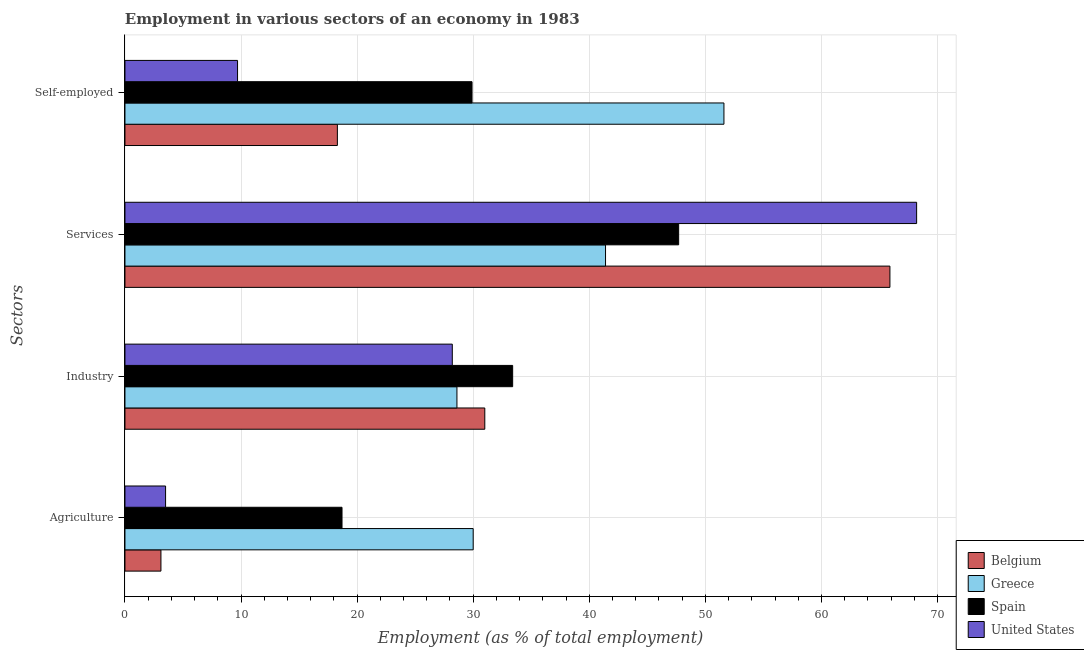How many different coloured bars are there?
Give a very brief answer. 4. How many groups of bars are there?
Offer a terse response. 4. Are the number of bars per tick equal to the number of legend labels?
Provide a succinct answer. Yes. Are the number of bars on each tick of the Y-axis equal?
Keep it short and to the point. Yes. What is the label of the 3rd group of bars from the top?
Keep it short and to the point. Industry. What is the percentage of self employed workers in Belgium?
Your answer should be very brief. 18.3. Across all countries, what is the maximum percentage of workers in industry?
Provide a succinct answer. 33.4. Across all countries, what is the minimum percentage of workers in services?
Provide a succinct answer. 41.4. What is the total percentage of workers in industry in the graph?
Offer a very short reply. 121.2. What is the difference between the percentage of workers in industry in United States and that in Belgium?
Offer a very short reply. -2.8. What is the difference between the percentage of self employed workers in Belgium and the percentage of workers in industry in Greece?
Provide a succinct answer. -10.3. What is the average percentage of workers in industry per country?
Provide a succinct answer. 30.3. What is the difference between the percentage of self employed workers and percentage of workers in services in Belgium?
Your answer should be compact. -47.6. What is the ratio of the percentage of workers in services in Greece to that in Spain?
Ensure brevity in your answer.  0.87. Is the percentage of workers in industry in Greece less than that in Spain?
Your answer should be very brief. Yes. Is the difference between the percentage of self employed workers in Spain and United States greater than the difference between the percentage of workers in services in Spain and United States?
Your answer should be compact. Yes. What is the difference between the highest and the second highest percentage of workers in industry?
Offer a very short reply. 2.4. What is the difference between the highest and the lowest percentage of workers in industry?
Provide a succinct answer. 5.2. Is the sum of the percentage of self employed workers in Greece and United States greater than the maximum percentage of workers in services across all countries?
Make the answer very short. No. Is it the case that in every country, the sum of the percentage of self employed workers and percentage of workers in services is greater than the sum of percentage of workers in agriculture and percentage of workers in industry?
Your response must be concise. No. What does the 1st bar from the bottom in Services represents?
Offer a very short reply. Belgium. Is it the case that in every country, the sum of the percentage of workers in agriculture and percentage of workers in industry is greater than the percentage of workers in services?
Your answer should be compact. No. How many bars are there?
Your response must be concise. 16. How many countries are there in the graph?
Your answer should be compact. 4. What is the difference between two consecutive major ticks on the X-axis?
Your answer should be compact. 10. Are the values on the major ticks of X-axis written in scientific E-notation?
Your answer should be compact. No. Does the graph contain any zero values?
Your response must be concise. No. Does the graph contain grids?
Offer a terse response. Yes. How many legend labels are there?
Make the answer very short. 4. How are the legend labels stacked?
Ensure brevity in your answer.  Vertical. What is the title of the graph?
Your answer should be very brief. Employment in various sectors of an economy in 1983. Does "Hungary" appear as one of the legend labels in the graph?
Give a very brief answer. No. What is the label or title of the X-axis?
Provide a succinct answer. Employment (as % of total employment). What is the label or title of the Y-axis?
Provide a short and direct response. Sectors. What is the Employment (as % of total employment) in Belgium in Agriculture?
Provide a succinct answer. 3.1. What is the Employment (as % of total employment) in Greece in Agriculture?
Provide a short and direct response. 30. What is the Employment (as % of total employment) in Spain in Agriculture?
Offer a terse response. 18.7. What is the Employment (as % of total employment) of Belgium in Industry?
Provide a succinct answer. 31. What is the Employment (as % of total employment) of Greece in Industry?
Give a very brief answer. 28.6. What is the Employment (as % of total employment) of Spain in Industry?
Offer a very short reply. 33.4. What is the Employment (as % of total employment) in United States in Industry?
Your answer should be very brief. 28.2. What is the Employment (as % of total employment) of Belgium in Services?
Your response must be concise. 65.9. What is the Employment (as % of total employment) in Greece in Services?
Offer a very short reply. 41.4. What is the Employment (as % of total employment) of Spain in Services?
Your answer should be very brief. 47.7. What is the Employment (as % of total employment) in United States in Services?
Provide a succinct answer. 68.2. What is the Employment (as % of total employment) in Belgium in Self-employed?
Provide a succinct answer. 18.3. What is the Employment (as % of total employment) of Greece in Self-employed?
Offer a terse response. 51.6. What is the Employment (as % of total employment) in Spain in Self-employed?
Keep it short and to the point. 29.9. What is the Employment (as % of total employment) of United States in Self-employed?
Offer a very short reply. 9.7. Across all Sectors, what is the maximum Employment (as % of total employment) in Belgium?
Provide a succinct answer. 65.9. Across all Sectors, what is the maximum Employment (as % of total employment) in Greece?
Provide a succinct answer. 51.6. Across all Sectors, what is the maximum Employment (as % of total employment) in Spain?
Your response must be concise. 47.7. Across all Sectors, what is the maximum Employment (as % of total employment) in United States?
Your answer should be compact. 68.2. Across all Sectors, what is the minimum Employment (as % of total employment) of Belgium?
Your response must be concise. 3.1. Across all Sectors, what is the minimum Employment (as % of total employment) of Greece?
Provide a succinct answer. 28.6. Across all Sectors, what is the minimum Employment (as % of total employment) in Spain?
Provide a short and direct response. 18.7. Across all Sectors, what is the minimum Employment (as % of total employment) of United States?
Offer a very short reply. 3.5. What is the total Employment (as % of total employment) in Belgium in the graph?
Provide a short and direct response. 118.3. What is the total Employment (as % of total employment) in Greece in the graph?
Your answer should be compact. 151.6. What is the total Employment (as % of total employment) in Spain in the graph?
Your answer should be compact. 129.7. What is the total Employment (as % of total employment) of United States in the graph?
Your answer should be very brief. 109.6. What is the difference between the Employment (as % of total employment) of Belgium in Agriculture and that in Industry?
Keep it short and to the point. -27.9. What is the difference between the Employment (as % of total employment) of Greece in Agriculture and that in Industry?
Offer a very short reply. 1.4. What is the difference between the Employment (as % of total employment) of Spain in Agriculture and that in Industry?
Provide a short and direct response. -14.7. What is the difference between the Employment (as % of total employment) in United States in Agriculture and that in Industry?
Ensure brevity in your answer.  -24.7. What is the difference between the Employment (as % of total employment) of Belgium in Agriculture and that in Services?
Give a very brief answer. -62.8. What is the difference between the Employment (as % of total employment) of United States in Agriculture and that in Services?
Your answer should be very brief. -64.7. What is the difference between the Employment (as % of total employment) of Belgium in Agriculture and that in Self-employed?
Keep it short and to the point. -15.2. What is the difference between the Employment (as % of total employment) in Greece in Agriculture and that in Self-employed?
Your response must be concise. -21.6. What is the difference between the Employment (as % of total employment) in Belgium in Industry and that in Services?
Ensure brevity in your answer.  -34.9. What is the difference between the Employment (as % of total employment) in Spain in Industry and that in Services?
Provide a succinct answer. -14.3. What is the difference between the Employment (as % of total employment) in United States in Industry and that in Services?
Make the answer very short. -40. What is the difference between the Employment (as % of total employment) of Belgium in Industry and that in Self-employed?
Your response must be concise. 12.7. What is the difference between the Employment (as % of total employment) in Spain in Industry and that in Self-employed?
Offer a very short reply. 3.5. What is the difference between the Employment (as % of total employment) of Belgium in Services and that in Self-employed?
Provide a short and direct response. 47.6. What is the difference between the Employment (as % of total employment) of Greece in Services and that in Self-employed?
Your answer should be compact. -10.2. What is the difference between the Employment (as % of total employment) of United States in Services and that in Self-employed?
Offer a very short reply. 58.5. What is the difference between the Employment (as % of total employment) in Belgium in Agriculture and the Employment (as % of total employment) in Greece in Industry?
Offer a terse response. -25.5. What is the difference between the Employment (as % of total employment) of Belgium in Agriculture and the Employment (as % of total employment) of Spain in Industry?
Offer a terse response. -30.3. What is the difference between the Employment (as % of total employment) of Belgium in Agriculture and the Employment (as % of total employment) of United States in Industry?
Give a very brief answer. -25.1. What is the difference between the Employment (as % of total employment) of Spain in Agriculture and the Employment (as % of total employment) of United States in Industry?
Make the answer very short. -9.5. What is the difference between the Employment (as % of total employment) in Belgium in Agriculture and the Employment (as % of total employment) in Greece in Services?
Your answer should be compact. -38.3. What is the difference between the Employment (as % of total employment) of Belgium in Agriculture and the Employment (as % of total employment) of Spain in Services?
Your answer should be compact. -44.6. What is the difference between the Employment (as % of total employment) in Belgium in Agriculture and the Employment (as % of total employment) in United States in Services?
Your answer should be compact. -65.1. What is the difference between the Employment (as % of total employment) in Greece in Agriculture and the Employment (as % of total employment) in Spain in Services?
Make the answer very short. -17.7. What is the difference between the Employment (as % of total employment) in Greece in Agriculture and the Employment (as % of total employment) in United States in Services?
Your answer should be compact. -38.2. What is the difference between the Employment (as % of total employment) in Spain in Agriculture and the Employment (as % of total employment) in United States in Services?
Your answer should be very brief. -49.5. What is the difference between the Employment (as % of total employment) of Belgium in Agriculture and the Employment (as % of total employment) of Greece in Self-employed?
Offer a terse response. -48.5. What is the difference between the Employment (as % of total employment) in Belgium in Agriculture and the Employment (as % of total employment) in Spain in Self-employed?
Make the answer very short. -26.8. What is the difference between the Employment (as % of total employment) in Greece in Agriculture and the Employment (as % of total employment) in Spain in Self-employed?
Offer a terse response. 0.1. What is the difference between the Employment (as % of total employment) of Greece in Agriculture and the Employment (as % of total employment) of United States in Self-employed?
Provide a succinct answer. 20.3. What is the difference between the Employment (as % of total employment) of Spain in Agriculture and the Employment (as % of total employment) of United States in Self-employed?
Give a very brief answer. 9. What is the difference between the Employment (as % of total employment) of Belgium in Industry and the Employment (as % of total employment) of Spain in Services?
Your answer should be compact. -16.7. What is the difference between the Employment (as % of total employment) in Belgium in Industry and the Employment (as % of total employment) in United States in Services?
Your response must be concise. -37.2. What is the difference between the Employment (as % of total employment) in Greece in Industry and the Employment (as % of total employment) in Spain in Services?
Provide a short and direct response. -19.1. What is the difference between the Employment (as % of total employment) in Greece in Industry and the Employment (as % of total employment) in United States in Services?
Your answer should be compact. -39.6. What is the difference between the Employment (as % of total employment) in Spain in Industry and the Employment (as % of total employment) in United States in Services?
Give a very brief answer. -34.8. What is the difference between the Employment (as % of total employment) in Belgium in Industry and the Employment (as % of total employment) in Greece in Self-employed?
Give a very brief answer. -20.6. What is the difference between the Employment (as % of total employment) in Belgium in Industry and the Employment (as % of total employment) in Spain in Self-employed?
Give a very brief answer. 1.1. What is the difference between the Employment (as % of total employment) of Belgium in Industry and the Employment (as % of total employment) of United States in Self-employed?
Give a very brief answer. 21.3. What is the difference between the Employment (as % of total employment) in Greece in Industry and the Employment (as % of total employment) in Spain in Self-employed?
Offer a terse response. -1.3. What is the difference between the Employment (as % of total employment) of Greece in Industry and the Employment (as % of total employment) of United States in Self-employed?
Make the answer very short. 18.9. What is the difference between the Employment (as % of total employment) of Spain in Industry and the Employment (as % of total employment) of United States in Self-employed?
Ensure brevity in your answer.  23.7. What is the difference between the Employment (as % of total employment) of Belgium in Services and the Employment (as % of total employment) of Greece in Self-employed?
Ensure brevity in your answer.  14.3. What is the difference between the Employment (as % of total employment) in Belgium in Services and the Employment (as % of total employment) in Spain in Self-employed?
Offer a terse response. 36. What is the difference between the Employment (as % of total employment) of Belgium in Services and the Employment (as % of total employment) of United States in Self-employed?
Ensure brevity in your answer.  56.2. What is the difference between the Employment (as % of total employment) in Greece in Services and the Employment (as % of total employment) in Spain in Self-employed?
Provide a short and direct response. 11.5. What is the difference between the Employment (as % of total employment) in Greece in Services and the Employment (as % of total employment) in United States in Self-employed?
Provide a short and direct response. 31.7. What is the difference between the Employment (as % of total employment) of Spain in Services and the Employment (as % of total employment) of United States in Self-employed?
Provide a succinct answer. 38. What is the average Employment (as % of total employment) of Belgium per Sectors?
Give a very brief answer. 29.57. What is the average Employment (as % of total employment) in Greece per Sectors?
Your response must be concise. 37.9. What is the average Employment (as % of total employment) of Spain per Sectors?
Keep it short and to the point. 32.42. What is the average Employment (as % of total employment) in United States per Sectors?
Offer a very short reply. 27.4. What is the difference between the Employment (as % of total employment) of Belgium and Employment (as % of total employment) of Greece in Agriculture?
Provide a succinct answer. -26.9. What is the difference between the Employment (as % of total employment) in Belgium and Employment (as % of total employment) in Spain in Agriculture?
Your response must be concise. -15.6. What is the difference between the Employment (as % of total employment) of Greece and Employment (as % of total employment) of United States in Agriculture?
Make the answer very short. 26.5. What is the difference between the Employment (as % of total employment) of Belgium and Employment (as % of total employment) of Greece in Industry?
Ensure brevity in your answer.  2.4. What is the difference between the Employment (as % of total employment) in Belgium and Employment (as % of total employment) in United States in Industry?
Your answer should be very brief. 2.8. What is the difference between the Employment (as % of total employment) of Greece and Employment (as % of total employment) of Spain in Industry?
Your response must be concise. -4.8. What is the difference between the Employment (as % of total employment) of Greece and Employment (as % of total employment) of United States in Industry?
Give a very brief answer. 0.4. What is the difference between the Employment (as % of total employment) of Belgium and Employment (as % of total employment) of Spain in Services?
Offer a terse response. 18.2. What is the difference between the Employment (as % of total employment) in Belgium and Employment (as % of total employment) in United States in Services?
Provide a short and direct response. -2.3. What is the difference between the Employment (as % of total employment) in Greece and Employment (as % of total employment) in Spain in Services?
Your answer should be compact. -6.3. What is the difference between the Employment (as % of total employment) of Greece and Employment (as % of total employment) of United States in Services?
Ensure brevity in your answer.  -26.8. What is the difference between the Employment (as % of total employment) of Spain and Employment (as % of total employment) of United States in Services?
Your answer should be very brief. -20.5. What is the difference between the Employment (as % of total employment) of Belgium and Employment (as % of total employment) of Greece in Self-employed?
Your answer should be compact. -33.3. What is the difference between the Employment (as % of total employment) in Belgium and Employment (as % of total employment) in United States in Self-employed?
Offer a very short reply. 8.6. What is the difference between the Employment (as % of total employment) of Greece and Employment (as % of total employment) of Spain in Self-employed?
Offer a terse response. 21.7. What is the difference between the Employment (as % of total employment) of Greece and Employment (as % of total employment) of United States in Self-employed?
Offer a very short reply. 41.9. What is the difference between the Employment (as % of total employment) of Spain and Employment (as % of total employment) of United States in Self-employed?
Keep it short and to the point. 20.2. What is the ratio of the Employment (as % of total employment) in Belgium in Agriculture to that in Industry?
Provide a succinct answer. 0.1. What is the ratio of the Employment (as % of total employment) of Greece in Agriculture to that in Industry?
Provide a succinct answer. 1.05. What is the ratio of the Employment (as % of total employment) of Spain in Agriculture to that in Industry?
Ensure brevity in your answer.  0.56. What is the ratio of the Employment (as % of total employment) in United States in Agriculture to that in Industry?
Offer a terse response. 0.12. What is the ratio of the Employment (as % of total employment) in Belgium in Agriculture to that in Services?
Provide a succinct answer. 0.05. What is the ratio of the Employment (as % of total employment) in Greece in Agriculture to that in Services?
Offer a terse response. 0.72. What is the ratio of the Employment (as % of total employment) in Spain in Agriculture to that in Services?
Offer a terse response. 0.39. What is the ratio of the Employment (as % of total employment) of United States in Agriculture to that in Services?
Ensure brevity in your answer.  0.05. What is the ratio of the Employment (as % of total employment) of Belgium in Agriculture to that in Self-employed?
Provide a short and direct response. 0.17. What is the ratio of the Employment (as % of total employment) of Greece in Agriculture to that in Self-employed?
Make the answer very short. 0.58. What is the ratio of the Employment (as % of total employment) of Spain in Agriculture to that in Self-employed?
Your answer should be compact. 0.63. What is the ratio of the Employment (as % of total employment) in United States in Agriculture to that in Self-employed?
Ensure brevity in your answer.  0.36. What is the ratio of the Employment (as % of total employment) of Belgium in Industry to that in Services?
Ensure brevity in your answer.  0.47. What is the ratio of the Employment (as % of total employment) of Greece in Industry to that in Services?
Your answer should be very brief. 0.69. What is the ratio of the Employment (as % of total employment) in Spain in Industry to that in Services?
Provide a short and direct response. 0.7. What is the ratio of the Employment (as % of total employment) in United States in Industry to that in Services?
Make the answer very short. 0.41. What is the ratio of the Employment (as % of total employment) in Belgium in Industry to that in Self-employed?
Make the answer very short. 1.69. What is the ratio of the Employment (as % of total employment) of Greece in Industry to that in Self-employed?
Provide a short and direct response. 0.55. What is the ratio of the Employment (as % of total employment) of Spain in Industry to that in Self-employed?
Offer a very short reply. 1.12. What is the ratio of the Employment (as % of total employment) in United States in Industry to that in Self-employed?
Give a very brief answer. 2.91. What is the ratio of the Employment (as % of total employment) of Belgium in Services to that in Self-employed?
Offer a very short reply. 3.6. What is the ratio of the Employment (as % of total employment) of Greece in Services to that in Self-employed?
Offer a very short reply. 0.8. What is the ratio of the Employment (as % of total employment) in Spain in Services to that in Self-employed?
Your answer should be very brief. 1.6. What is the ratio of the Employment (as % of total employment) in United States in Services to that in Self-employed?
Provide a succinct answer. 7.03. What is the difference between the highest and the second highest Employment (as % of total employment) in Belgium?
Provide a short and direct response. 34.9. What is the difference between the highest and the lowest Employment (as % of total employment) of Belgium?
Offer a very short reply. 62.8. What is the difference between the highest and the lowest Employment (as % of total employment) of Greece?
Provide a succinct answer. 23. What is the difference between the highest and the lowest Employment (as % of total employment) of Spain?
Your answer should be very brief. 29. What is the difference between the highest and the lowest Employment (as % of total employment) of United States?
Give a very brief answer. 64.7. 